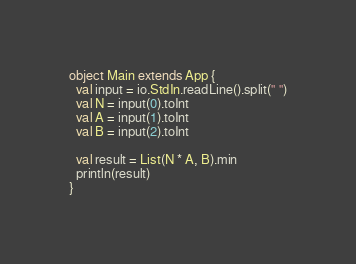<code> <loc_0><loc_0><loc_500><loc_500><_Scala_>object Main extends App {
  val input = io.StdIn.readLine().split(" ")
  val N = input(0).toInt
  val A = input(1).toInt
  val B = input(2).toInt
  
  val result = List(N * A, B).min
  println(result)
}</code> 